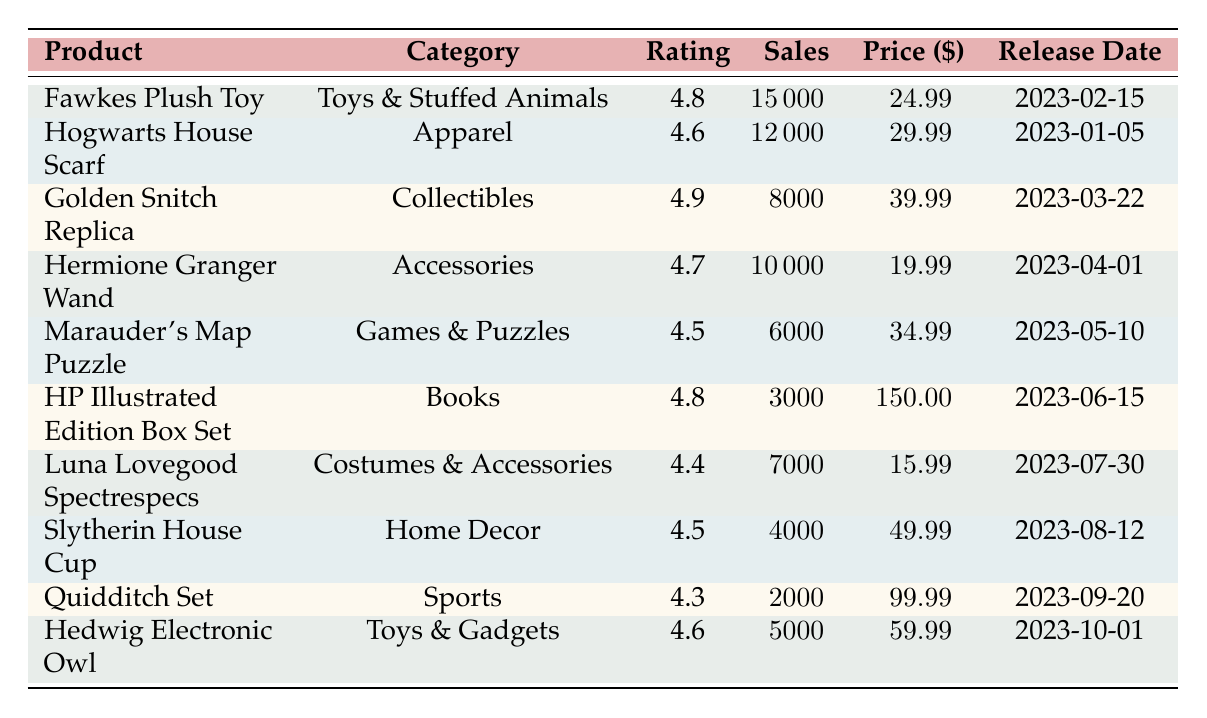What is the product with the highest popularity rating? The table lists the products along with their popularity ratings. The highest rating is 4.9, which belongs to the Golden Snitch Replica.
Answer: Golden Snitch Replica How many sales units did the Fawkes Plush Toy achieve? Looking at the row for the Fawkes Plush Toy, the table indicates that it achieved 15,000 sales units.
Answer: 15,000 What is the release date of the HP Illustrated Edition Box Set? The table shows that the HP Illustrated Edition Box Set was released on June 15, 2023.
Answer: 2023-06-15 Which product belongs to the Toys & Stuffed Animals category? The table shows that the Fawkes Plush Toy is classified under the category Toys & Stuffed Animals.
Answer: Fawkes Plush Toy What is the price of the Hedwig Electronic Owl? Referring to the Hedwig Electronic Owl row, it is priced at $59.99.
Answer: 59.99 What is the average popularity rating of all products listed? To find the average rating, sum the ratings (4.8 + 4.6 + 4.9 + 4.7 + 4.5 + 4.8 + 4.4 + 4.5 + 4.3 + 4.6 = 47.6) and divide by the number of products (10), resulting in an average rating of 4.76.
Answer: 4.76 How many more sales units did the Hogwarts House Scarf have compared to the Quidditch Set? The Hogwarts House Scarf sold 12,000 units and the Quidditch Set sold 2,000 units. The difference is 12,000 - 2,000 = 10,000 sales units.
Answer: 10,000 Is the price of the Marauder's Map Puzzle greater than $30? The price of the Marauder's Map Puzzle is $34.99, which is greater than $30, thus the answer is yes.
Answer: Yes Which product has the lowest popularity rating, and what is that rating? The lowest rating in the table is 4.3, associated with the Quidditch Set.
Answer: Quidditch Set, 4.3 If you combined the sales of the Fawkes Plush Toy and the Hermione Granger Wand, what would be the total sales units? Fawkes Plush Toy has 15,000 sales and Hermione Granger Wand has 10,000 sales. The total is 15,000 + 10,000 = 25,000 sales units.
Answer: 25,000 How many products have a popularity rating higher than 4.5? The products with ratings higher than 4.5 are: Fawkes Plush Toy (4.8), Golden Snitch Replica (4.9), Hermione Granger Wand (4.7), and Hedwig Electronic Owl (4.6). That makes 4 products.
Answer: 4 